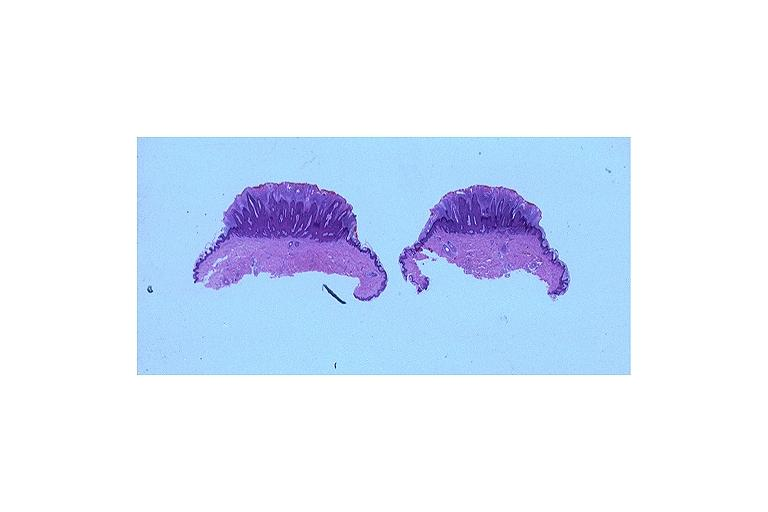s sac present?
Answer the question using a single word or phrase. No 